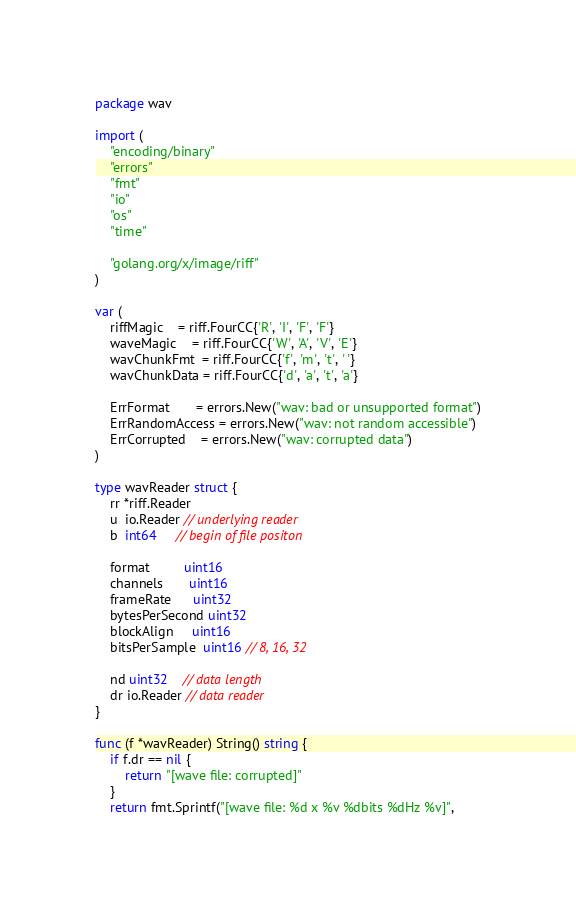<code> <loc_0><loc_0><loc_500><loc_500><_Go_>package wav

import (
	"encoding/binary"
	"errors"
	"fmt"
	"io"
	"os"
	"time"

	"golang.org/x/image/riff"
)

var (
	riffMagic    = riff.FourCC{'R', 'I', 'F', 'F'}
	waveMagic    = riff.FourCC{'W', 'A', 'V', 'E'}
	wavChunkFmt  = riff.FourCC{'f', 'm', 't', ' '}
	wavChunkData = riff.FourCC{'d', 'a', 't', 'a'}

	ErrFormat       = errors.New("wav: bad or unsupported format")
	ErrRandomAccess = errors.New("wav: not random accessible")
	ErrCorrupted    = errors.New("wav: corrupted data")
)

type wavReader struct {
	rr *riff.Reader
	u  io.Reader // underlying reader
	b  int64     // begin of file positon

	format         uint16
	channels       uint16
	frameRate      uint32
	bytesPerSecond uint32
	blockAlign     uint16
	bitsPerSample  uint16 // 8, 16, 32

	nd uint32    // data length
	dr io.Reader // data reader
}

func (f *wavReader) String() string {
	if f.dr == nil {
		return "[wave file: corrupted]"
	}
	return fmt.Sprintf("[wave file: %d x %v %dbits %dHz %v]",</code> 